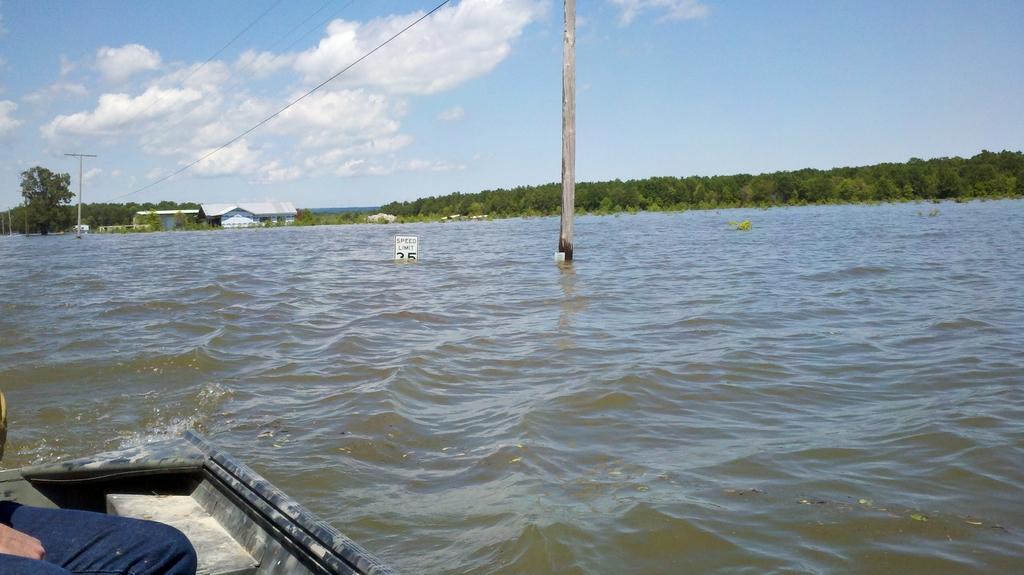How would you summarize this image in a sentence or two? In this picture we can see a person is sitting on a boat and the boat is on the water. Behind the boat there are electric poles with cables, trees, houses and the sky. 